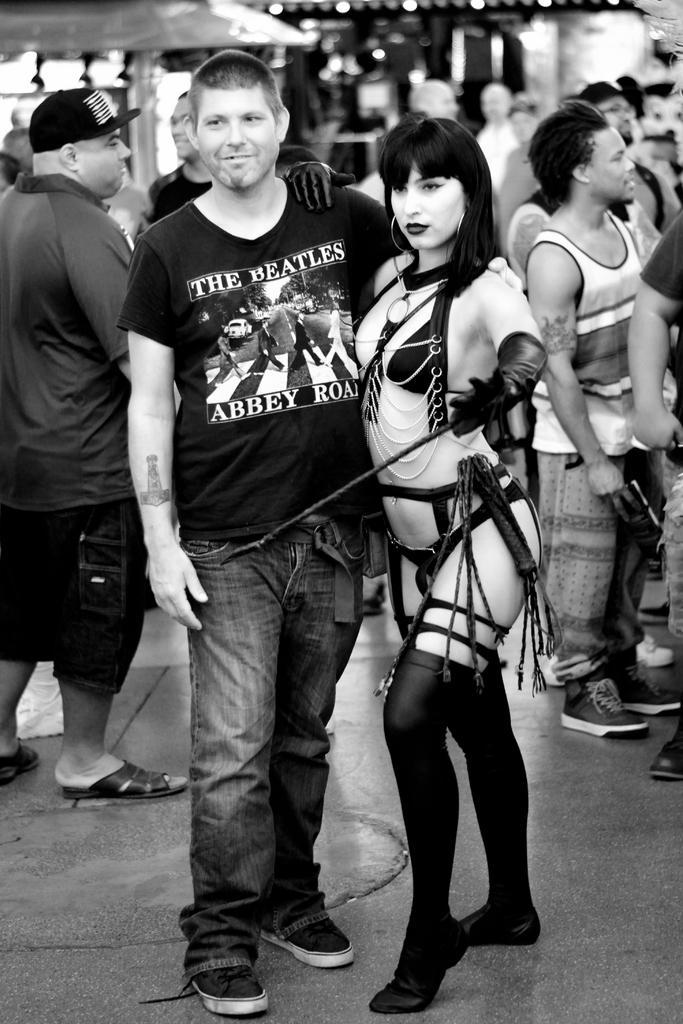How would you summarize this image in a sentence or two? There is a man and a woman in the foreground area of the image, there are people, it seems like roofs in the background. 